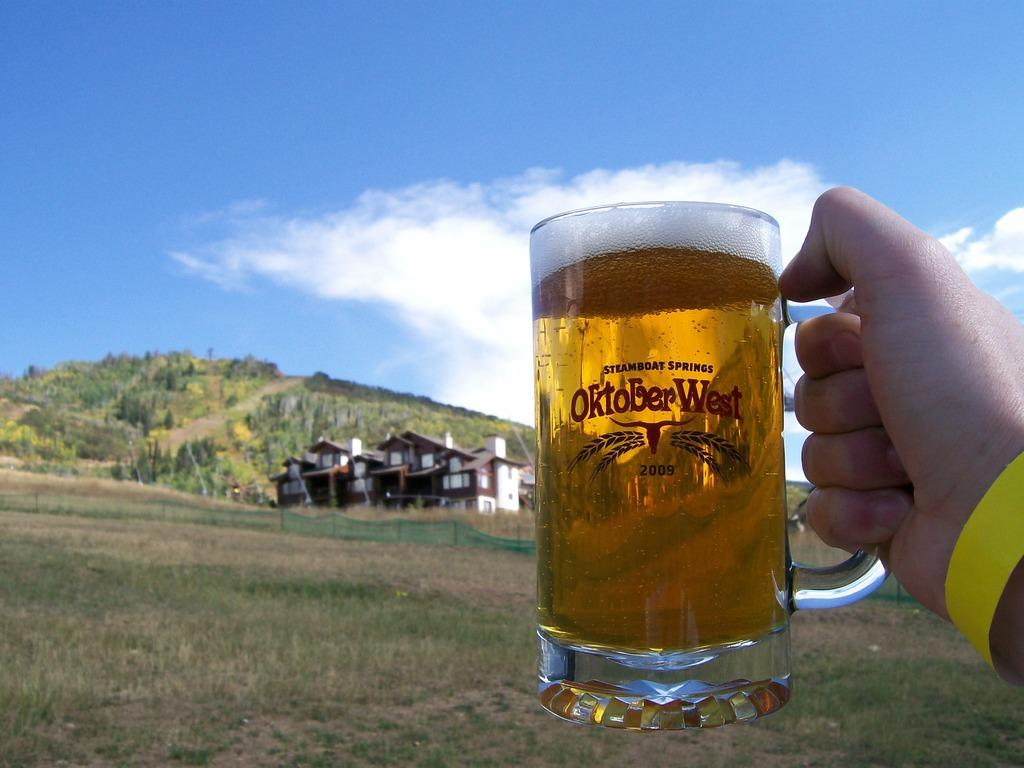<image>
Write a terse but informative summary of the picture. A glass of beer that says steamboat springs October West 